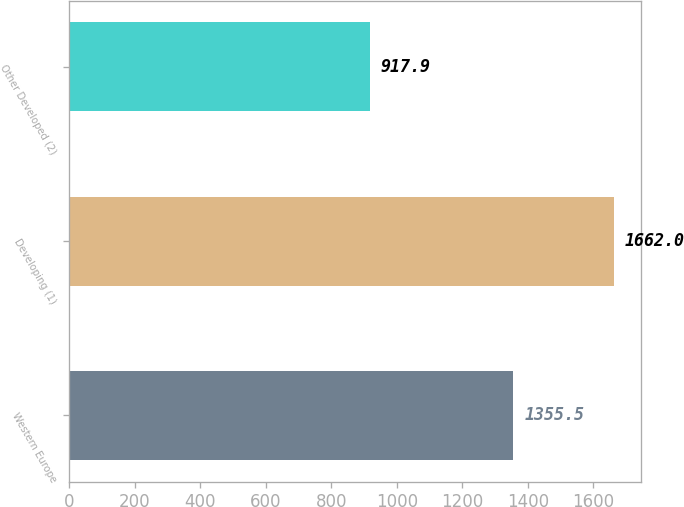Convert chart to OTSL. <chart><loc_0><loc_0><loc_500><loc_500><bar_chart><fcel>Western Europe<fcel>Developing (1)<fcel>Other Developed (2)<nl><fcel>1355.5<fcel>1662<fcel>917.9<nl></chart> 